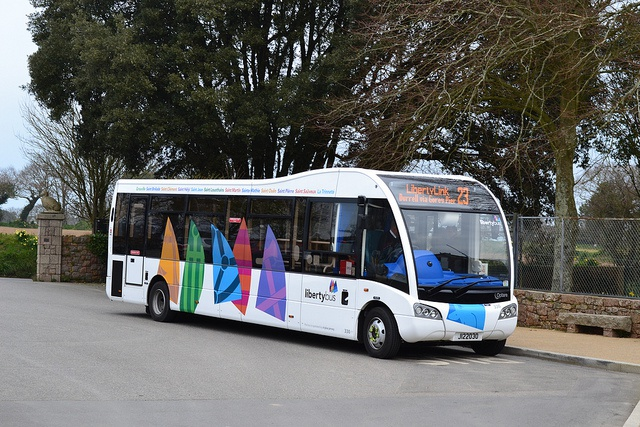Describe the objects in this image and their specific colors. I can see bus in white, black, lightgray, darkgray, and gray tones, bench in white, gray, and darkgray tones, and people in white, black, darkgray, and darkblue tones in this image. 